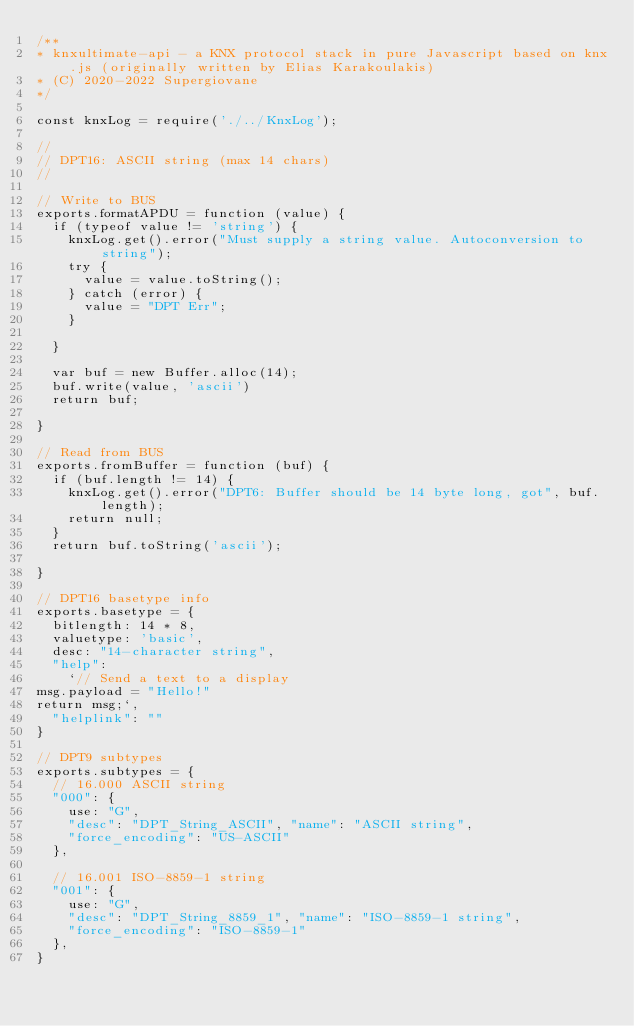<code> <loc_0><loc_0><loc_500><loc_500><_JavaScript_>/**
* knxultimate-api - a KNX protocol stack in pure Javascript based on knx.js (originally written by Elias Karakoulakis)
* (C) 2020-2022 Supergiovane
*/

const knxLog = require('./../KnxLog');

//
// DPT16: ASCII string (max 14 chars)
//

// Write to BUS
exports.formatAPDU = function (value) {
  if (typeof value != 'string') {
    knxLog.get().error("Must supply a string value. Autoconversion to string");
    try {
      value = value.toString();
    } catch (error) {
      value = "DPT Err";
    }

  }

  var buf = new Buffer.alloc(14);
  buf.write(value, 'ascii')
  return buf;

}

// Read from BUS
exports.fromBuffer = function (buf) {
  if (buf.length != 14) {
    knxLog.get().error("DPT6: Buffer should be 14 byte long, got", buf.length);
    return null;
  }
  return buf.toString('ascii');

}

// DPT16 basetype info
exports.basetype = {
  bitlength: 14 * 8,
  valuetype: 'basic',
  desc: "14-character string",
  "help":
    `// Send a text to a display
msg.payload = "Hello!"
return msg;`,
  "helplink": ""
}

// DPT9 subtypes
exports.subtypes = {
  // 16.000 ASCII string
  "000": {
    use: "G",
    "desc": "DPT_String_ASCII", "name": "ASCII string",
    "force_encoding": "US-ASCII"
  },

  // 16.001 ISO-8859-1 string
  "001": {
    use: "G",
    "desc": "DPT_String_8859_1", "name": "ISO-8859-1 string",
    "force_encoding": "ISO-8859-1"
  },
}
</code> 